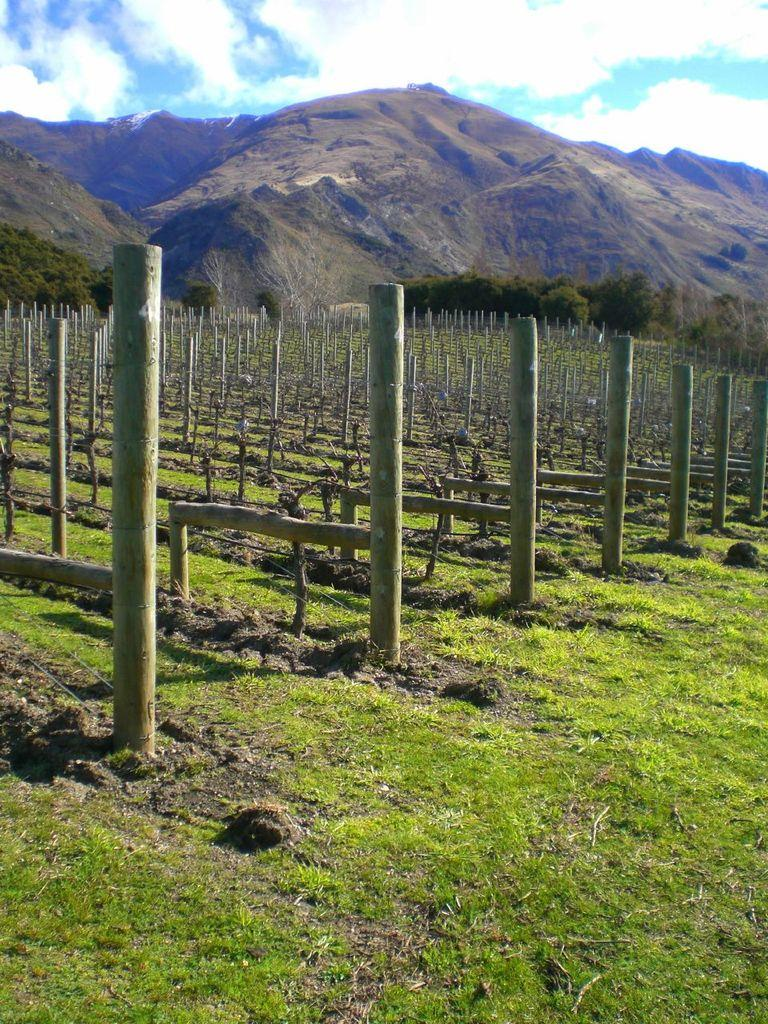What type of structures can be seen in the land in the image? There are wooden poles in the land in the image. What type of vegetation is visible behind the land? There are trees behind the land in the image. What natural features can be seen in the distance behind the land? There are mountains behind the land in the image. How many mice are playing musical instruments in harmony on the wooden poles? There are no mice or musical instruments present on the wooden poles in the image. 